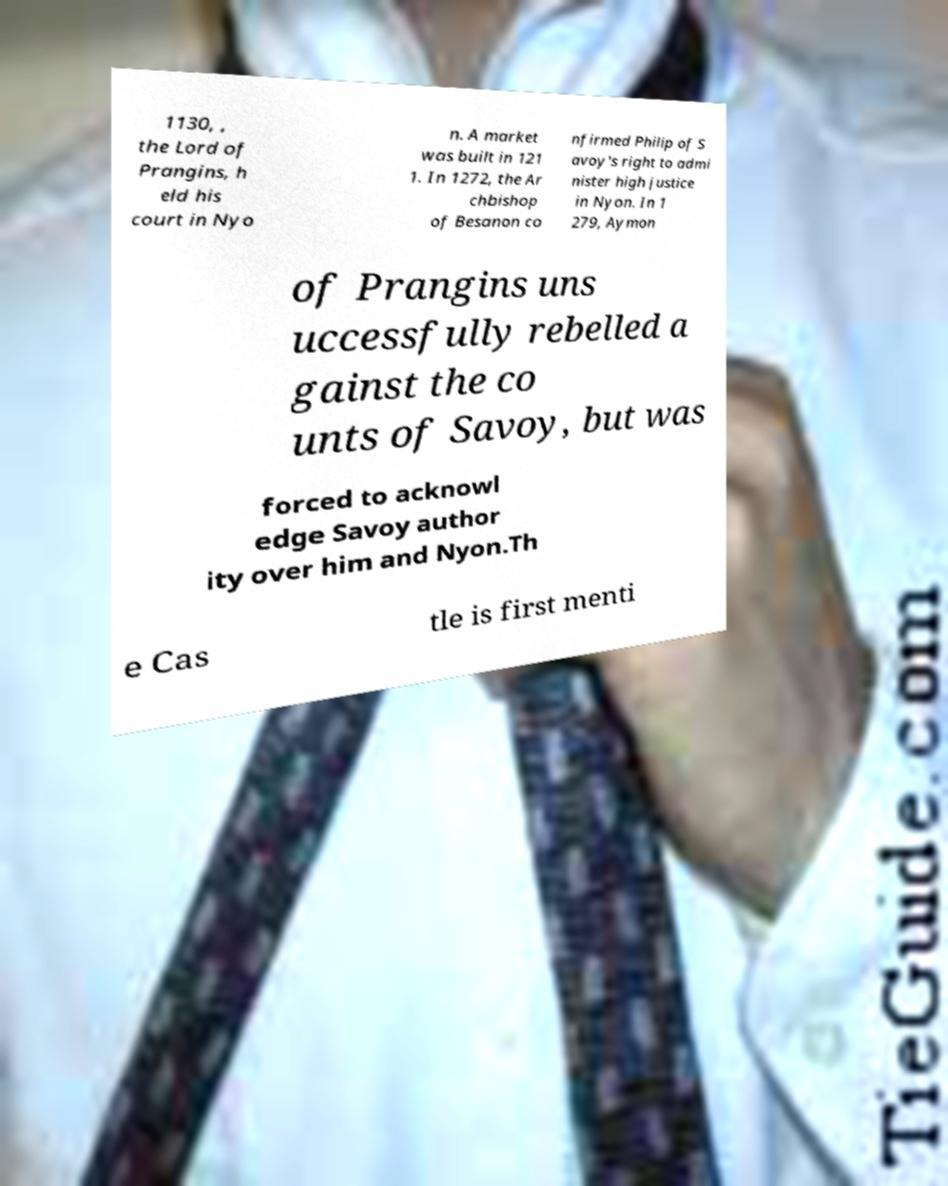Can you accurately transcribe the text from the provided image for me? 1130, , the Lord of Prangins, h eld his court in Nyo n. A market was built in 121 1. In 1272, the Ar chbishop of Besanon co nfirmed Philip of S avoy's right to admi nister high justice in Nyon. In 1 279, Aymon of Prangins uns uccessfully rebelled a gainst the co unts of Savoy, but was forced to acknowl edge Savoy author ity over him and Nyon.Th e Cas tle is first menti 